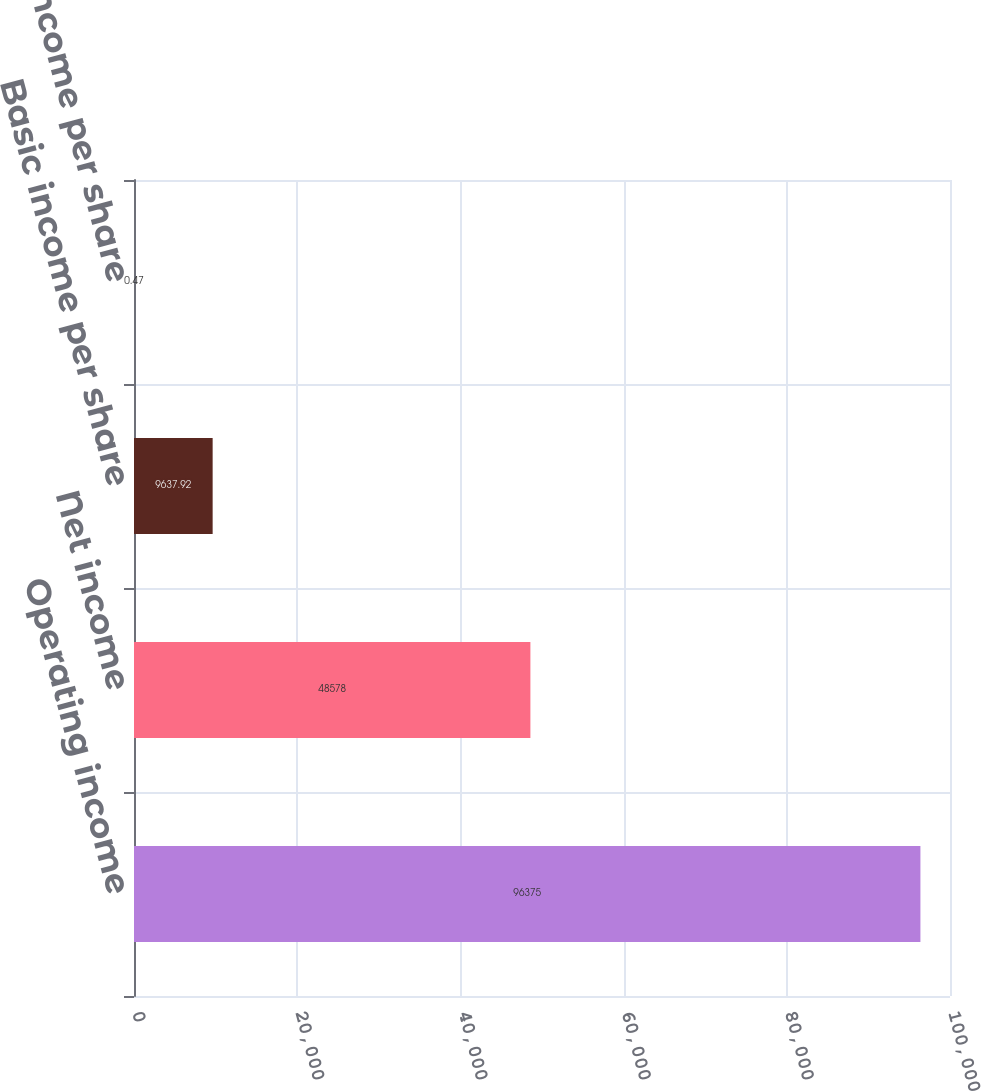Convert chart. <chart><loc_0><loc_0><loc_500><loc_500><bar_chart><fcel>Operating income<fcel>Net income<fcel>Basic income per share<fcel>Diluted income per share<nl><fcel>96375<fcel>48578<fcel>9637.92<fcel>0.47<nl></chart> 